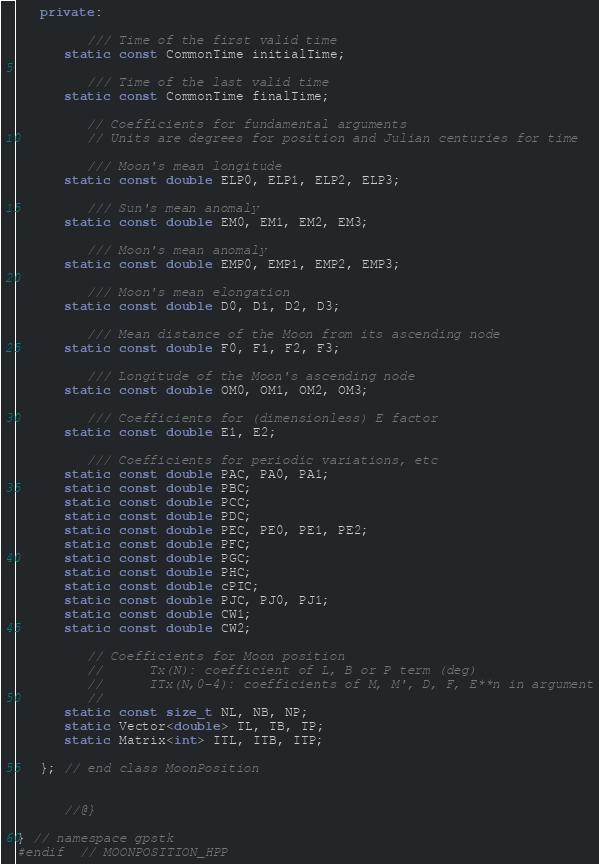Convert code to text. <code><loc_0><loc_0><loc_500><loc_500><_C++_>
   private:

         /// Time of the first valid time
      static const CommonTime initialTime;

         /// Time of the last valid time
      static const CommonTime finalTime;

         // Coefficients for fundamental arguments
         // Units are degrees for position and Julian centuries for time

         /// Moon's mean longitude
      static const double ELP0, ELP1, ELP2, ELP3;

         /// Sun's mean anomaly
      static const double EM0, EM1, EM2, EM3;

         /// Moon's mean anomaly
      static const double EMP0, EMP1, EMP2, EMP3;

         /// Moon's mean elongation
      static const double D0, D1, D2, D3;

         /// Mean distance of the Moon from its ascending node
      static const double F0, F1, F2, F3;

         /// Longitude of the Moon's ascending node
      static const double OM0, OM1, OM2, OM3;

         /// Coefficients for (dimensionless) E factor
      static const double E1, E2;

         /// Coefficients for periodic variations, etc
      static const double PAC, PA0, PA1;
      static const double PBC;
      static const double PCC;
      static const double PDC;
      static const double PEC, PE0, PE1, PE2;
      static const double PFC;
      static const double PGC;
      static const double PHC;
      static const double cPIC;
      static const double PJC, PJ0, PJ1;
      static const double CW1;
      static const double CW2;

         // Coefficients for Moon position
         //      Tx(N): coefficient of L, B or P term (deg)
         //      ITx(N,0-4): coefficients of M, M', D, F, E**n in argument
         //
      static const size_t NL, NB, NP;
      static Vector<double> TL, TB, TP;
      static Matrix<int> ITL, ITB, ITP;

   }; // end class MoonPosition


      //@}

} // namespace gpstk
#endif  // MOONPOSITION_HPP
</code> 